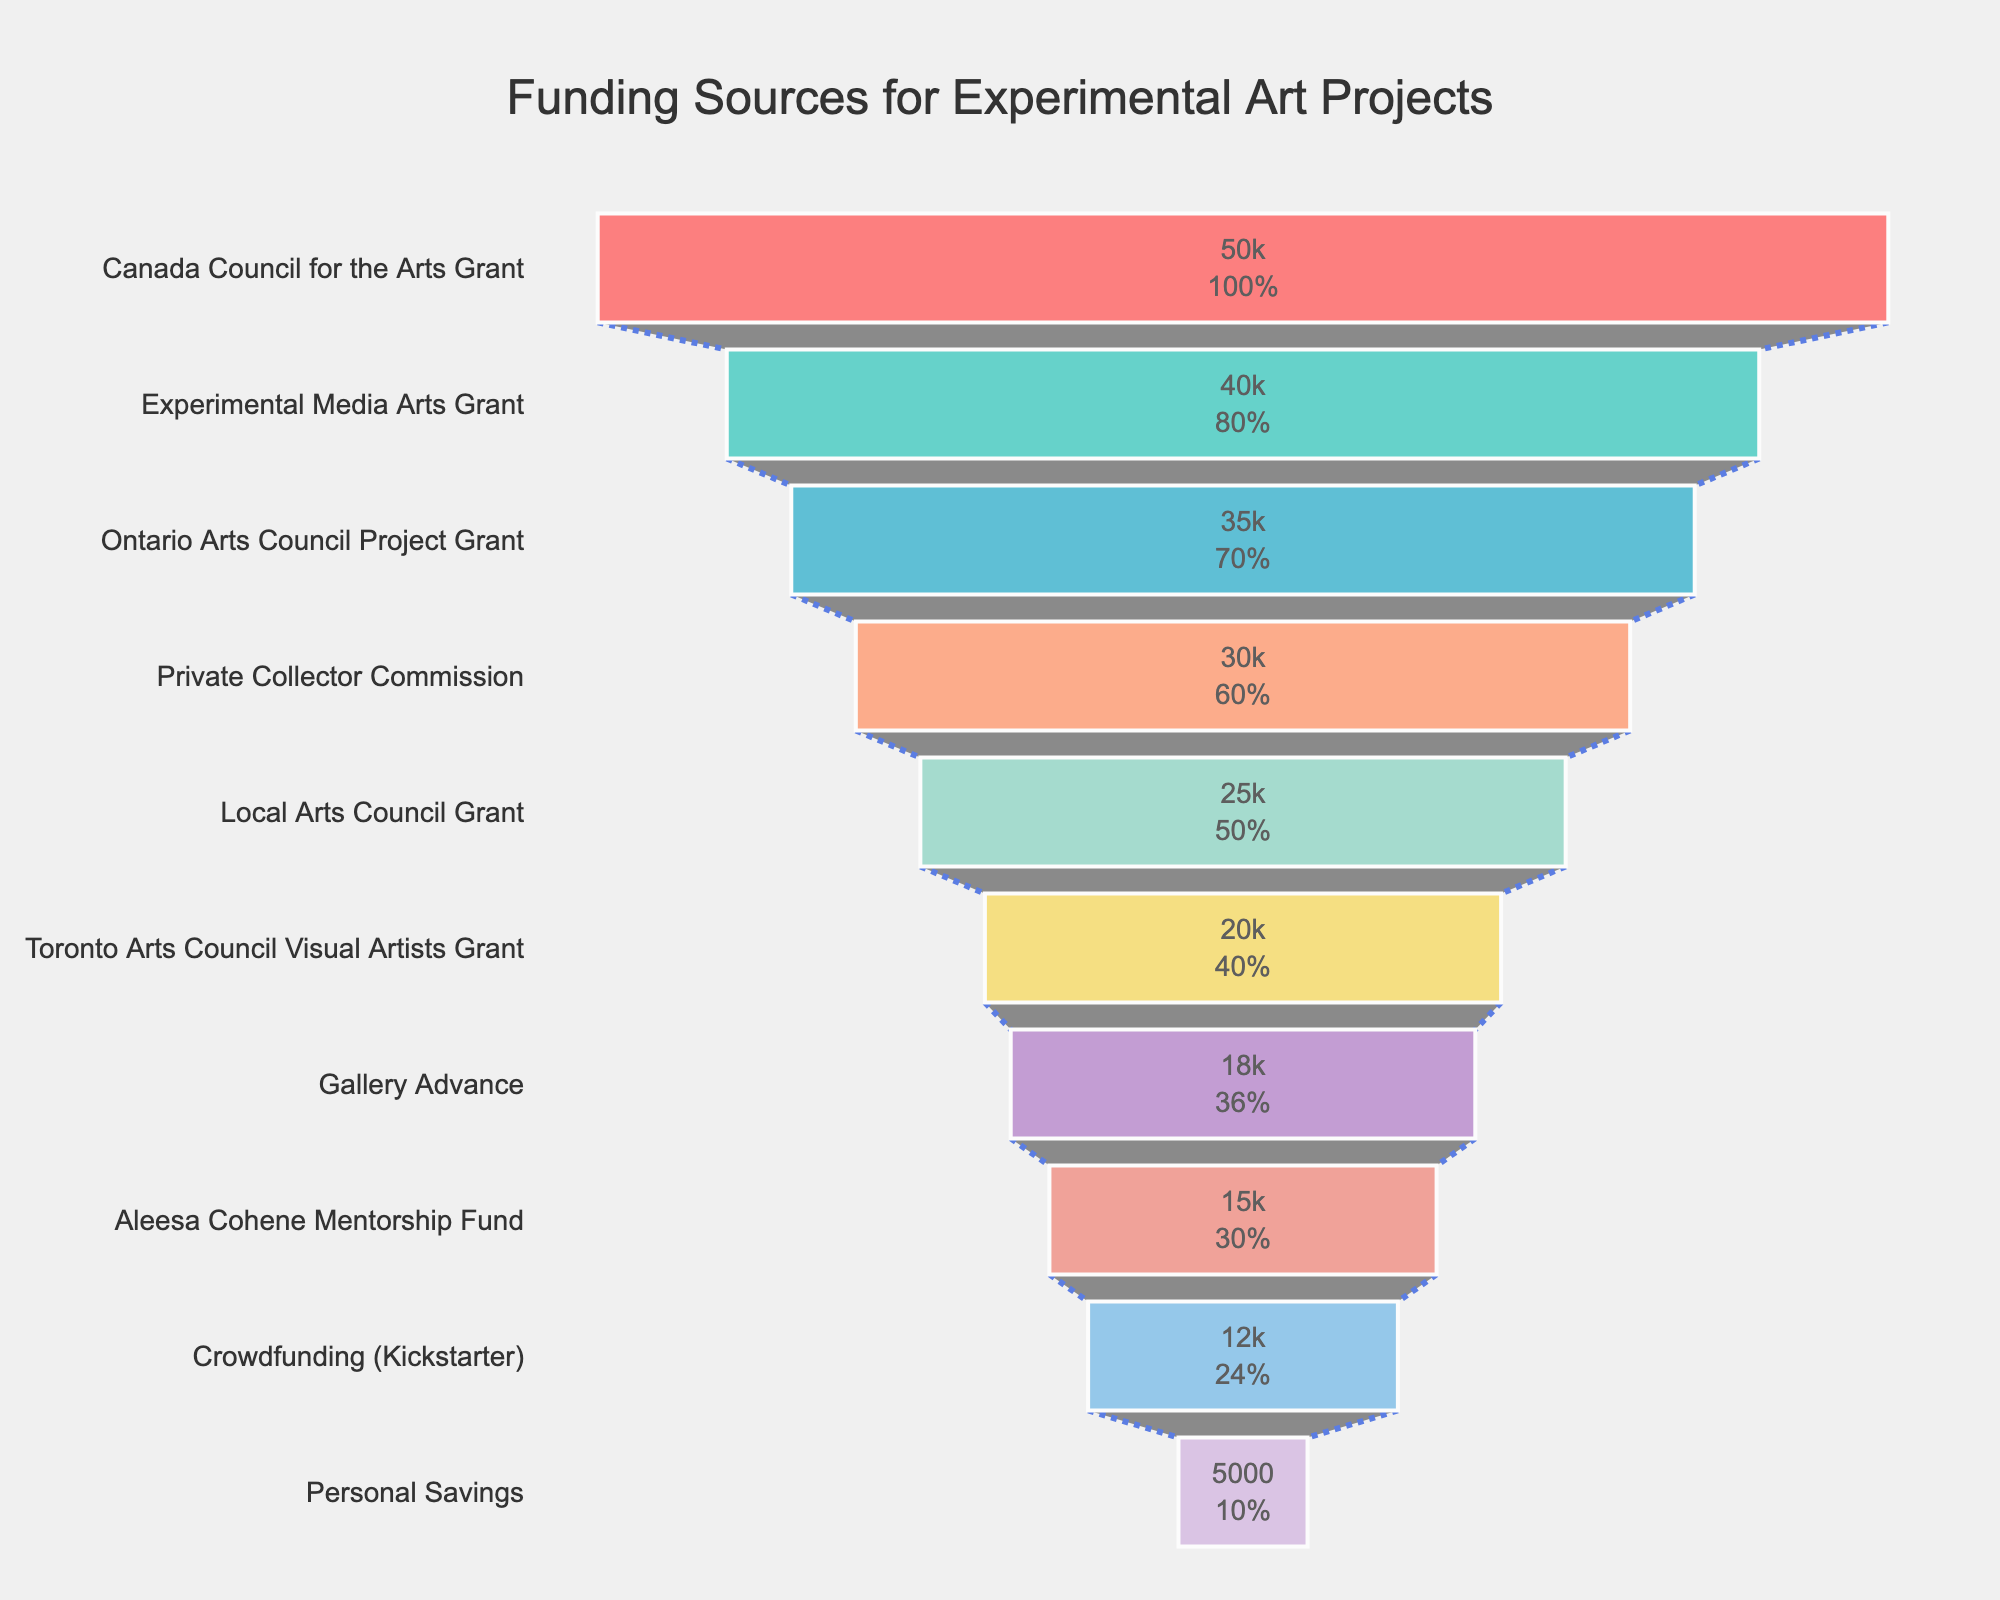What is the title of the funnel chart? The title is usually located at the top center of the funnel chart, visually larger and more prominent than other text. In this chart, it reads "Funding Sources for Experimental Art Projects."
Answer: Funding Sources for Experimental Art Projects How many funding sources are represented in the chart? The number of funding sources can be counted from the y-axis labels representing each funding source.
Answer: 10 Which funding source received the highest amount of funding? The funding source with the largest visual segment in the funnel chart has the highest amount. According to the data and the chart, it is the "Canada Council for the Arts Grant."
Answer: Canada Council for the Arts Grant Which funding source received the least amount of funding? The funding source with the smallest visual segment in the funnel chart has the least amount. In the chart, it is "Personal Savings."
Answer: Personal Savings How much funding did Aleesa Cohene Mentorship Fund provide? Locate "Aleesa Cohene Mentorship Fund" in the chart and read the corresponding amount from the x-axis or the text inside the segment. It shows $15,000.
Answer: $15,000 What is the total funding amount from all the sources combined? Sum all the amounts listed for each funding source from the provided data. $50,000 + $40,000 + $35,000 + $30,000 + $25,000 + $20,000 + $18,000 + $15,000 + $12,000 + $5,000 = $250,000.
Answer: $250,000 What percentage of total funding does the Experimental Media Arts Grant represent? First, identify the funding amount for the Experimental Media Arts Grant, which is $40,000. Then, divide this amount by the total funding ($250,000) and multiply by 100 to get the percentage. ($40,000 / $250,000) * 100 = 16%.
Answer: 16% How does the amount provided by the Private Collector Commission compare to that provided by the Gallery Advance? Compare the funding amounts for these two sources based on the chart. The Private Collector Commission is $30,000, whereas the Gallery Advance is $18,000. The Private Collector Commission provides $12,000 more than the Gallery Advance.
Answer: $12,000 more Which funding sources provided more than $30,000? Based on the chart and the data, funding sources with amounts greater than $30,000 are "Canada Council for the Arts Grant," "Experimental Media Arts Grant," and "Ontario Arts Council Project Grant."
Answer: Canada Council for the Arts Grant, Experimental Media Arts Grant, Ontario Arts Council Project Grant What is the combined funding from Toronto Arts Council Visual Artists Grant and Private Collector Commission? Sum the amounts provided by these two sources. Toronto Arts Council Visual Artists Grant: $20,000, Private Collector Commission: $30,000. $20,000 + $30,000 = $50,000.
Answer: $50,000 